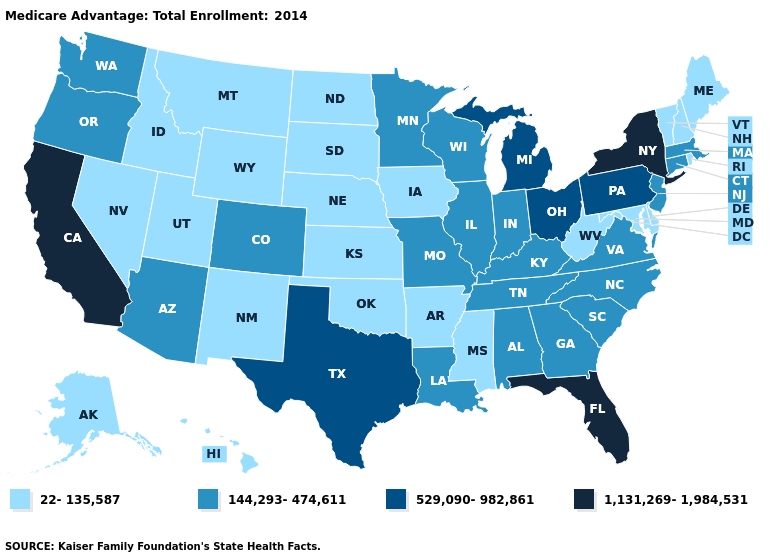Does Ohio have the highest value in the MidWest?
Be succinct. Yes. What is the lowest value in the South?
Answer briefly. 22-135,587. Among the states that border Colorado , does Nebraska have the lowest value?
Write a very short answer. Yes. Does the map have missing data?
Quick response, please. No. What is the lowest value in states that border Florida?
Concise answer only. 144,293-474,611. Does New Hampshire have the lowest value in the Northeast?
Write a very short answer. Yes. Does Pennsylvania have the same value as Texas?
Answer briefly. Yes. What is the value of South Carolina?
Give a very brief answer. 144,293-474,611. What is the value of Connecticut?
Give a very brief answer. 144,293-474,611. What is the lowest value in the West?
Short answer required. 22-135,587. How many symbols are there in the legend?
Be succinct. 4. Name the states that have a value in the range 144,293-474,611?
Concise answer only. Alabama, Arizona, Colorado, Connecticut, Georgia, Illinois, Indiana, Kentucky, Louisiana, Massachusetts, Minnesota, Missouri, North Carolina, New Jersey, Oregon, South Carolina, Tennessee, Virginia, Washington, Wisconsin. Name the states that have a value in the range 1,131,269-1,984,531?
Be succinct. California, Florida, New York. Name the states that have a value in the range 22-135,587?
Give a very brief answer. Alaska, Arkansas, Delaware, Hawaii, Iowa, Idaho, Kansas, Maryland, Maine, Mississippi, Montana, North Dakota, Nebraska, New Hampshire, New Mexico, Nevada, Oklahoma, Rhode Island, South Dakota, Utah, Vermont, West Virginia, Wyoming. Does the first symbol in the legend represent the smallest category?
Be succinct. Yes. 